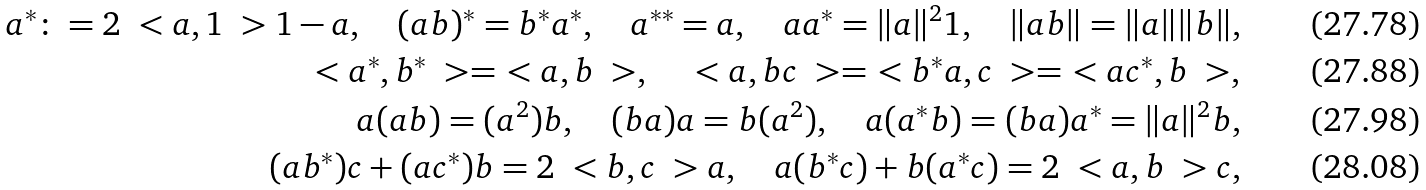Convert formula to latex. <formula><loc_0><loc_0><loc_500><loc_500>a ^ { * } \colon = 2 \ < a , 1 \ > 1 - a , \quad ( a b ) ^ { * } = b ^ { * } a ^ { * } , \quad a ^ { * * } = a , \quad a a ^ { * } = \| a \| ^ { 2 } 1 , \quad \| a b \| = \| a \| \| b \| , \\ \ < a ^ { * } , b ^ { * } \ > = \ < a , b \ > , \quad \ < a , b c \ > = \ < b ^ { * } a , c \ > = \ < a c ^ { * } , b \ > , \\ a ( a b ) = ( a ^ { 2 } ) b , \quad ( b a ) a = b ( a ^ { 2 } ) , \quad a ( a ^ { * } b ) = ( b a ) a ^ { * } = \| a \| ^ { 2 } b , \\ ( a b ^ { * } ) c + ( a c ^ { * } ) b = 2 \ < b , c \ > a , \quad a ( b ^ { * } c ) + b ( a ^ { * } c ) = 2 \ < a , b \ > c ,</formula> 